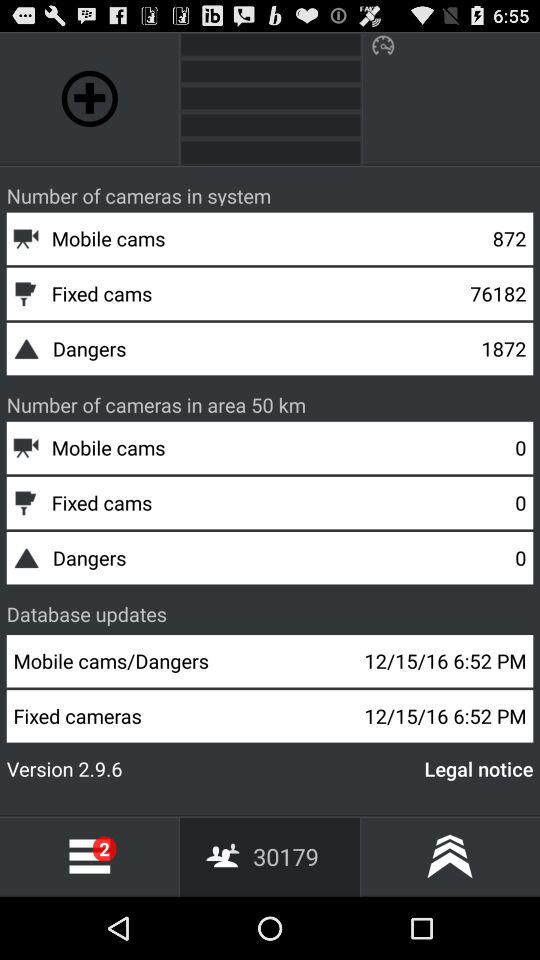How many more mobile cameras are there in the system than in the area within 50km?
Answer the question using a single word or phrase. 872 